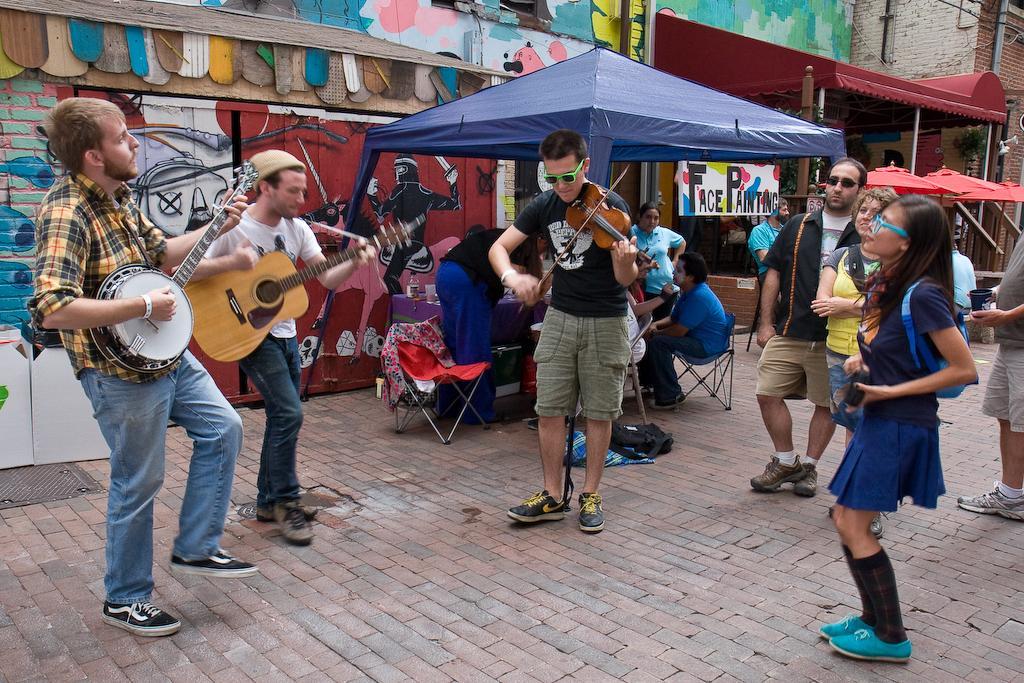Please provide a concise description of this image. In this image there are group of people. Few people are playing the musical instruments few are sitting on the chair. 